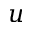Convert formula to latex. <formula><loc_0><loc_0><loc_500><loc_500>u</formula> 